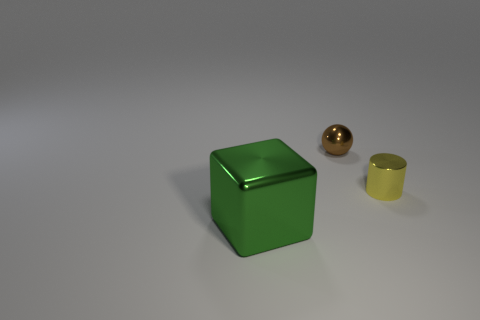Do the large block and the small shiny object in front of the sphere have the same color?
Keep it short and to the point. No. Is the number of large gray shiny spheres greater than the number of tiny brown objects?
Provide a succinct answer. No. Does the small sphere have the same material as the thing in front of the small cylinder?
Offer a terse response. Yes. How many objects are either small brown matte balls or large metal cubes?
Give a very brief answer. 1. Does the thing that is to the left of the tiny metallic sphere have the same size as the object that is behind the cylinder?
Offer a very short reply. No. How many blocks are large green things or tiny yellow objects?
Ensure brevity in your answer.  1. Is there a small gray object?
Make the answer very short. No. Is there any other thing that is the same shape as the brown metal object?
Your response must be concise. No. Is the small cylinder the same color as the large shiny block?
Ensure brevity in your answer.  No. What number of things are small things that are to the left of the yellow metal cylinder or cyan matte cylinders?
Your response must be concise. 1. 